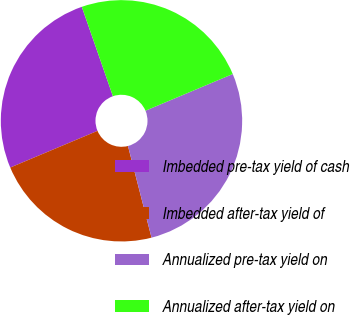<chart> <loc_0><loc_0><loc_500><loc_500><pie_chart><fcel>Imbedded pre-tax yield of cash<fcel>Imbedded after-tax yield of<fcel>Annualized pre-tax yield on<fcel>Annualized after-tax yield on<nl><fcel>26.0%<fcel>22.67%<fcel>27.33%<fcel>24.0%<nl></chart> 